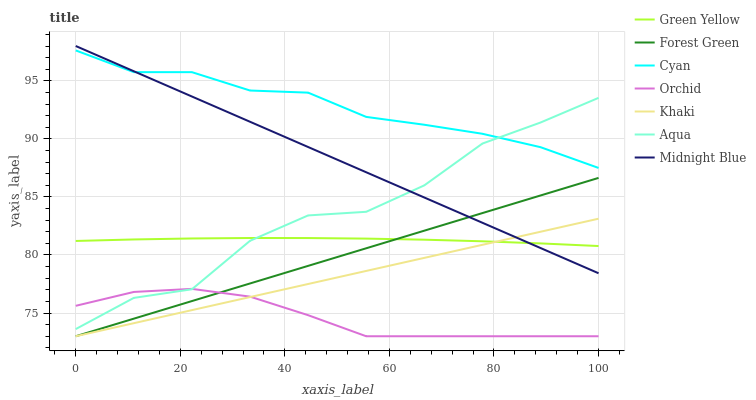Does Orchid have the minimum area under the curve?
Answer yes or no. Yes. Does Cyan have the maximum area under the curve?
Answer yes or no. Yes. Does Midnight Blue have the minimum area under the curve?
Answer yes or no. No. Does Midnight Blue have the maximum area under the curve?
Answer yes or no. No. Is Khaki the smoothest?
Answer yes or no. Yes. Is Aqua the roughest?
Answer yes or no. Yes. Is Midnight Blue the smoothest?
Answer yes or no. No. Is Midnight Blue the roughest?
Answer yes or no. No. Does Khaki have the lowest value?
Answer yes or no. Yes. Does Midnight Blue have the lowest value?
Answer yes or no. No. Does Midnight Blue have the highest value?
Answer yes or no. Yes. Does Aqua have the highest value?
Answer yes or no. No. Is Khaki less than Cyan?
Answer yes or no. Yes. Is Cyan greater than Green Yellow?
Answer yes or no. Yes. Does Khaki intersect Forest Green?
Answer yes or no. Yes. Is Khaki less than Forest Green?
Answer yes or no. No. Is Khaki greater than Forest Green?
Answer yes or no. No. Does Khaki intersect Cyan?
Answer yes or no. No. 